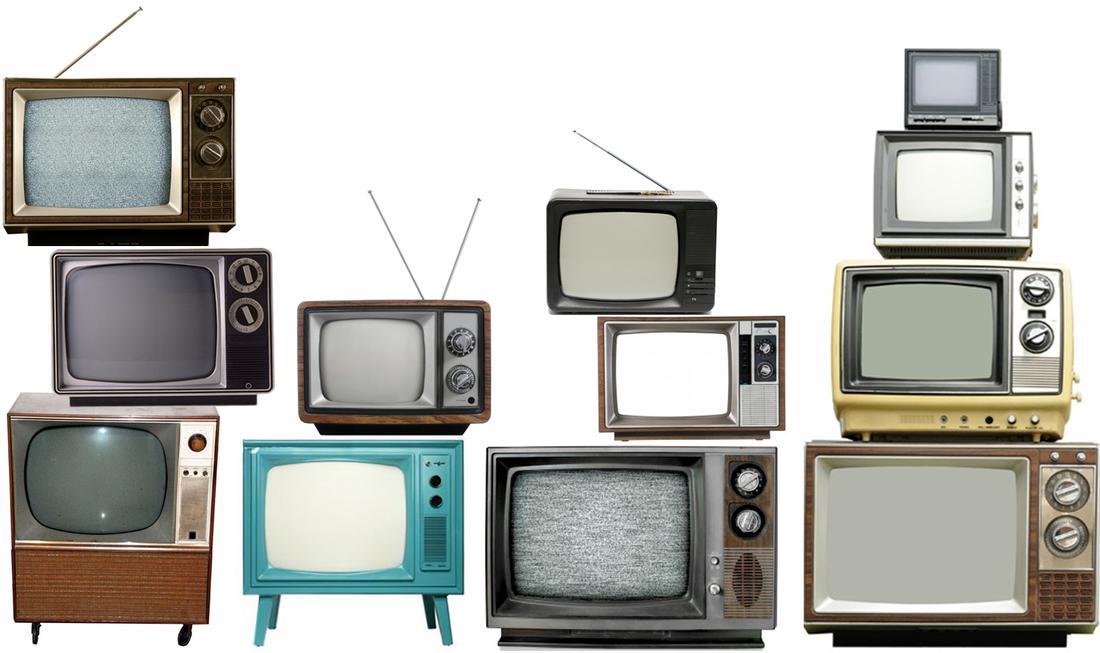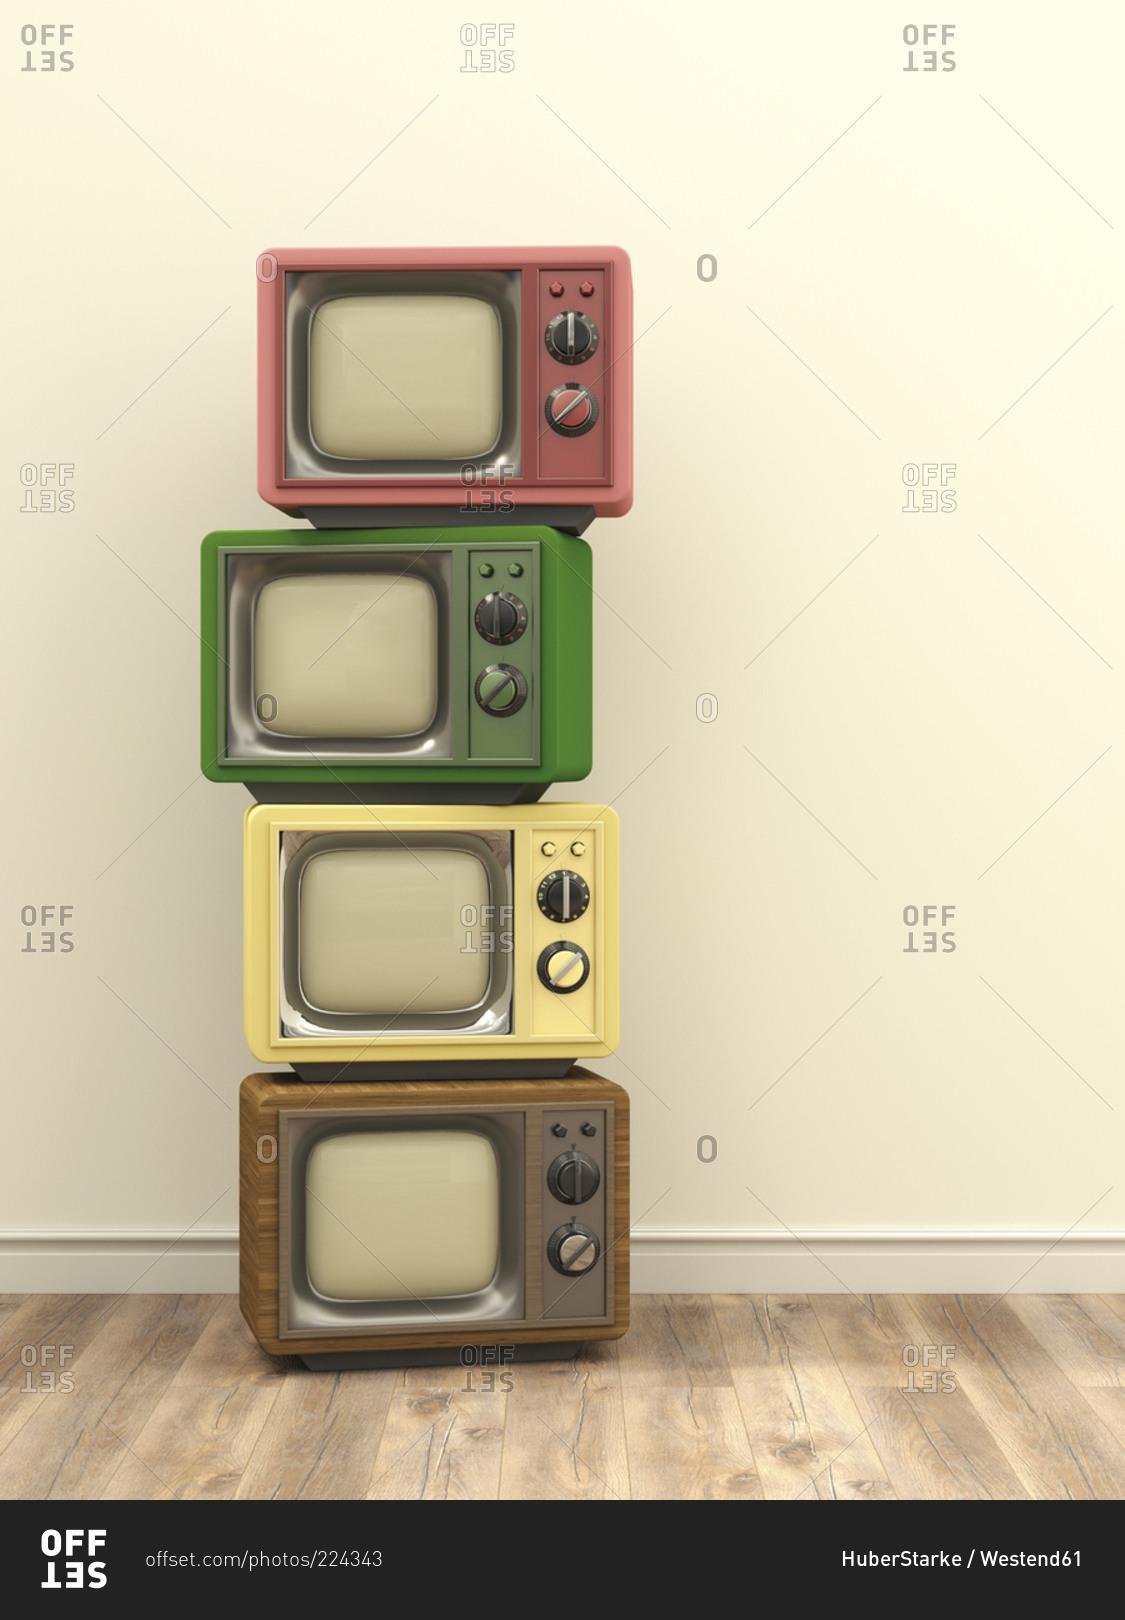The first image is the image on the left, the second image is the image on the right. For the images displayed, is the sentence "An image includes a vertical stack of four TVs, stacked from the biggest on the bottom to the smallest on top." factually correct? Answer yes or no. Yes. The first image is the image on the left, the second image is the image on the right. Assess this claim about the two images: "One image includes only a single television set.". Correct or not? Answer yes or no. No. 